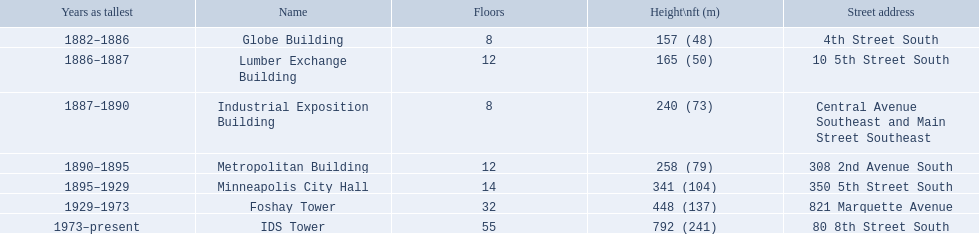How many floors does the globe building have? 8. Which building has 14 floors? Minneapolis City Hall. The lumber exchange building has the same number of floors as which building? Metropolitan Building. 